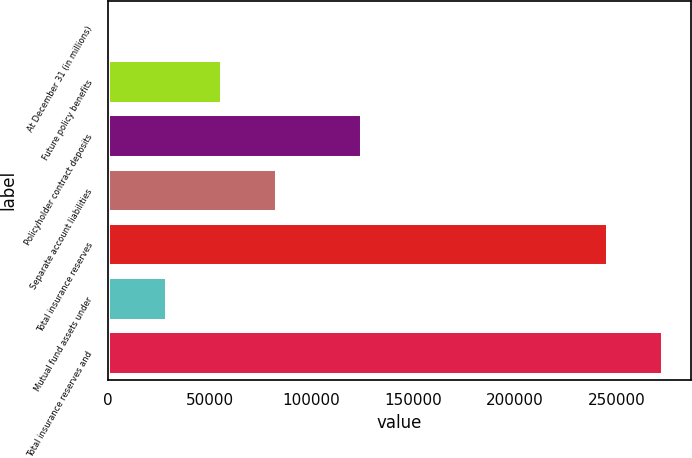<chart> <loc_0><loc_0><loc_500><loc_500><bar_chart><fcel>At December 31 (in millions)<fcel>Future policy benefits<fcel>Policyholder contract deposits<fcel>Separate account liabilities<fcel>Total insurance reserves<fcel>Mutual fund assets under<fcel>Total insurance reserves and<nl><fcel>2014<fcel>56156<fcel>124716<fcel>83227<fcel>245672<fcel>29085<fcel>272743<nl></chart> 